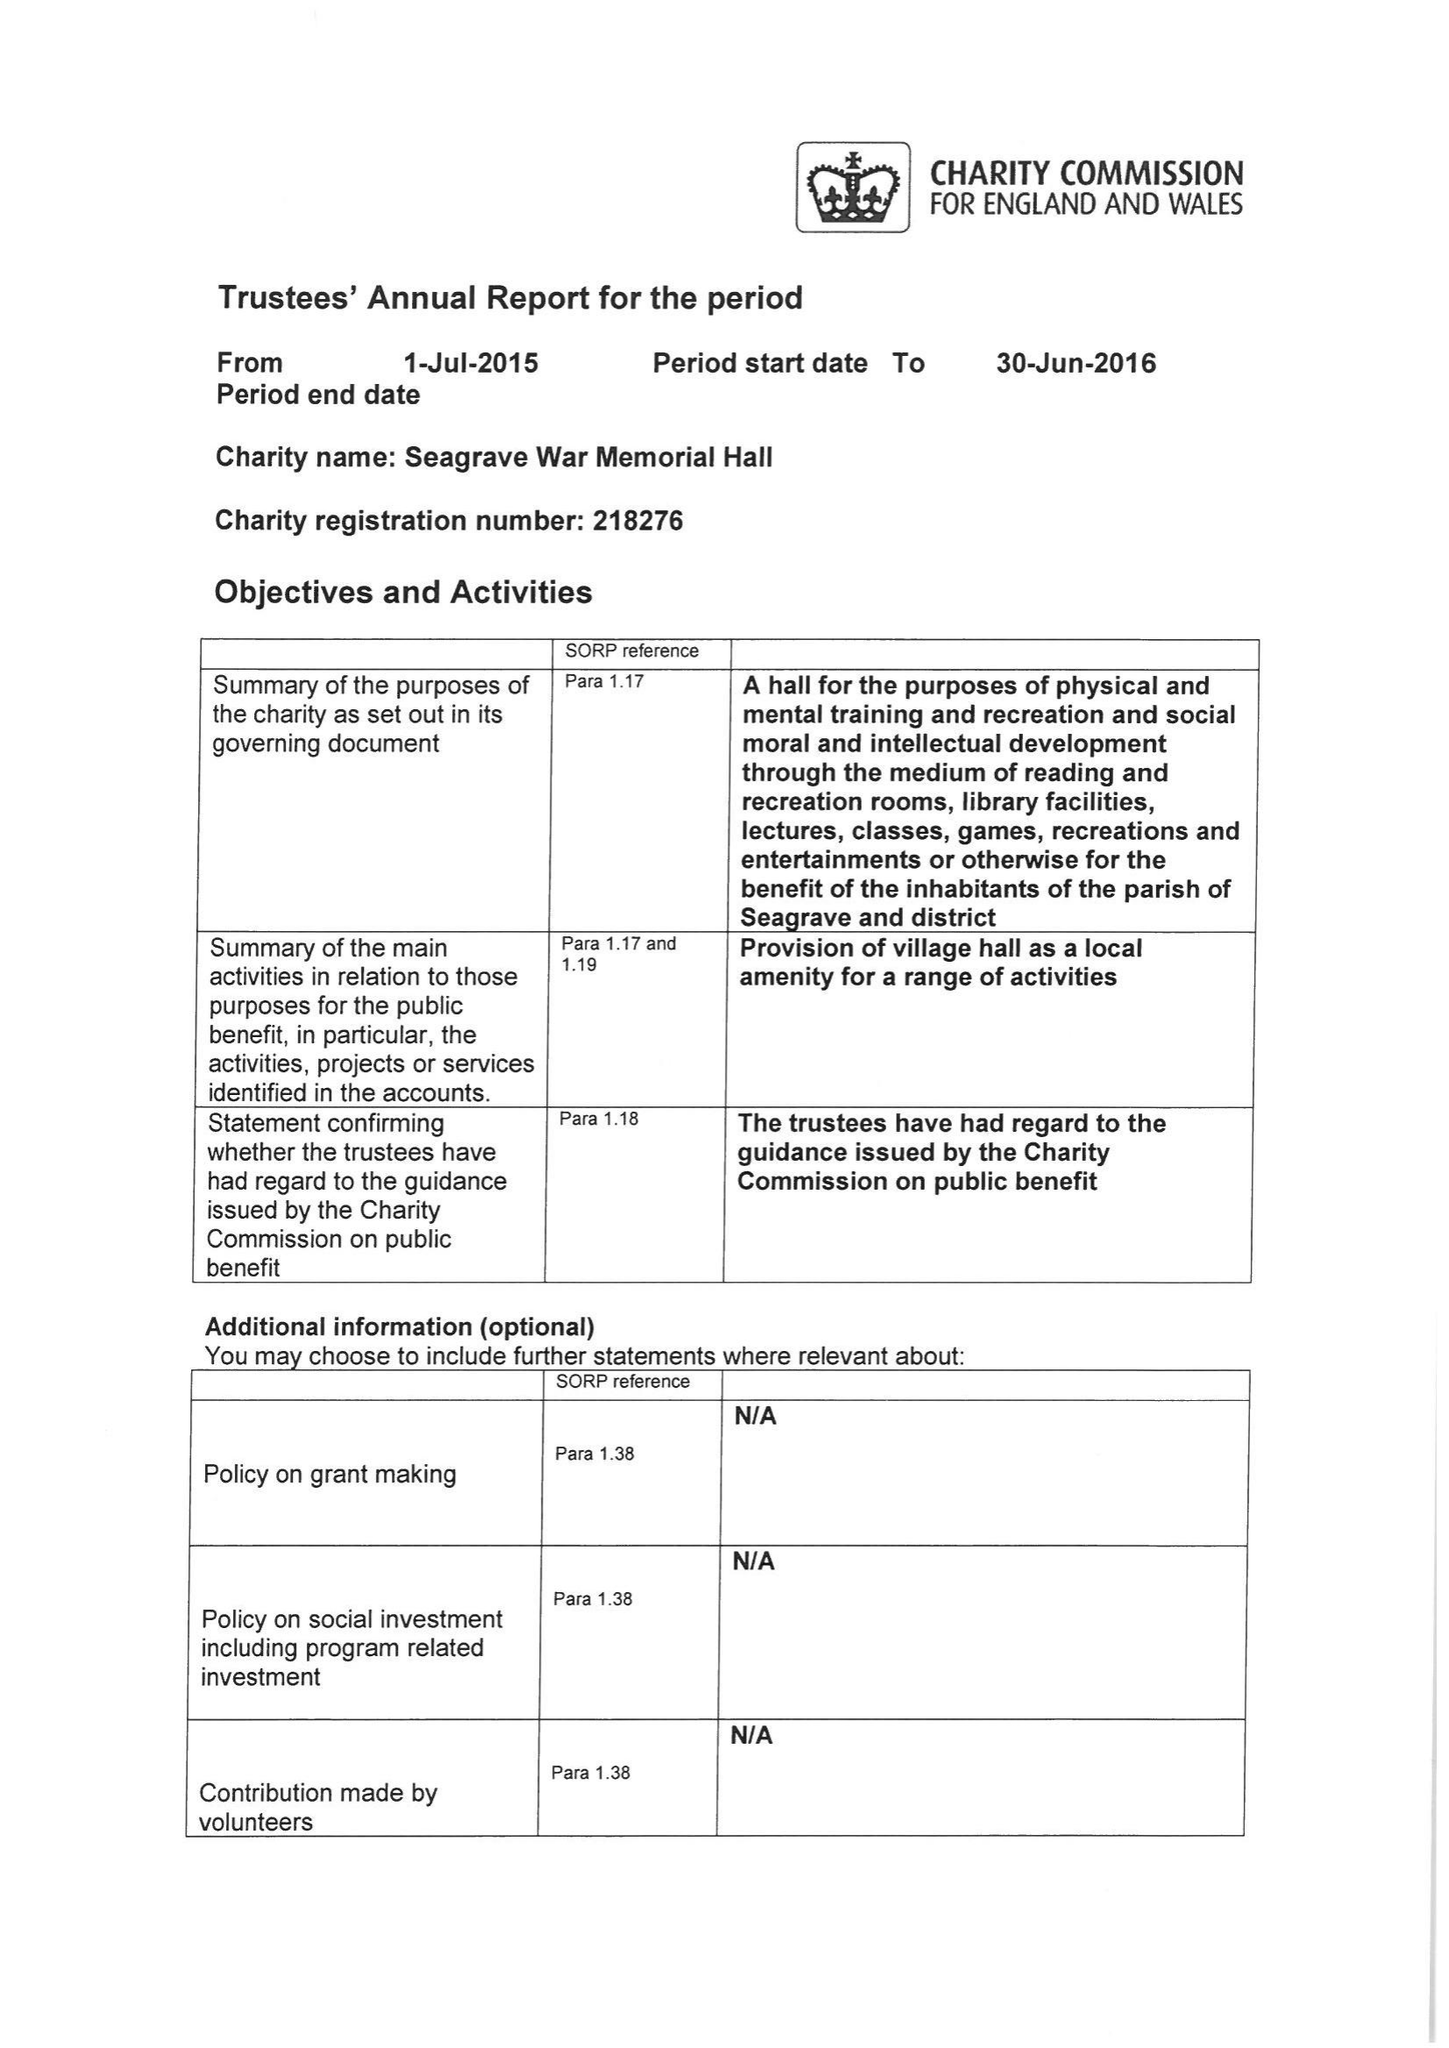What is the value for the report_date?
Answer the question using a single word or phrase. 2016-06-30 